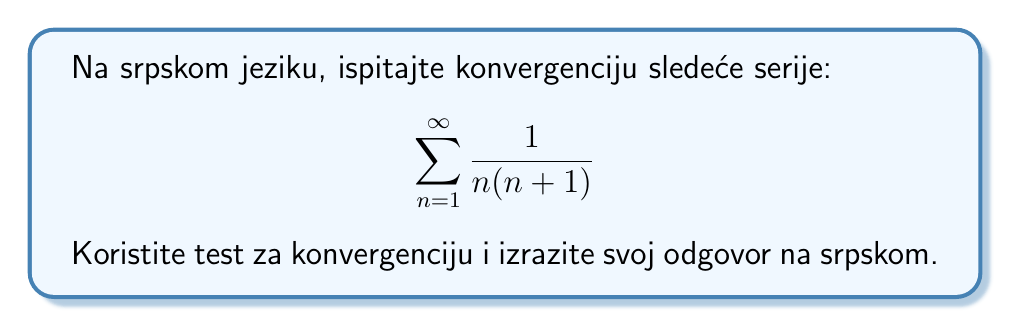Can you solve this math problem? Da bismo ispitali konvergenciju ove serije, koristićemo test poređenja sa teleskopskom serijom. Postupak je sledeći:

1) Prvo, primetimo da se opšti član serije može napisati kao razlika razlomaka:

   $$\frac{1}{n(n+1)} = \frac{1}{n} - \frac{1}{n+1}$$

2) Sada možemo napisati sumu prvih $m$ članova serije:

   $$S_m = \sum_{n=1}^{m} \frac{1}{n(n+1)} = \sum_{n=1}^{m} (\frac{1}{n} - \frac{1}{n+1})$$

3) Ova suma je teleskopska. Kada je raširimo, dobijamo:

   $$S_m = (1 - \frac{1}{2}) + (\frac{1}{2} - \frac{1}{3}) + (\frac{1}{3} - \frac{1}{4}) + ... + (\frac{1}{m} - \frac{1}{m+1})$$

4) Svi međučlanovi se poništavaju, ostavljajući nam:

   $$S_m = 1 - \frac{1}{m+1}$$

5) Kada $m$ teži beskonačnosti, $\frac{1}{m+1}$ teži nuli, pa imamo:

   $$\lim_{m \to \infty} S_m = 1$$

6) Pošto ovaj limes postoji i konačan je, zaključujemo da serija konvergira.

Dakle, serija konvergira i njena suma je 1.
Answer: Serija konvergira i njena suma je 1. 